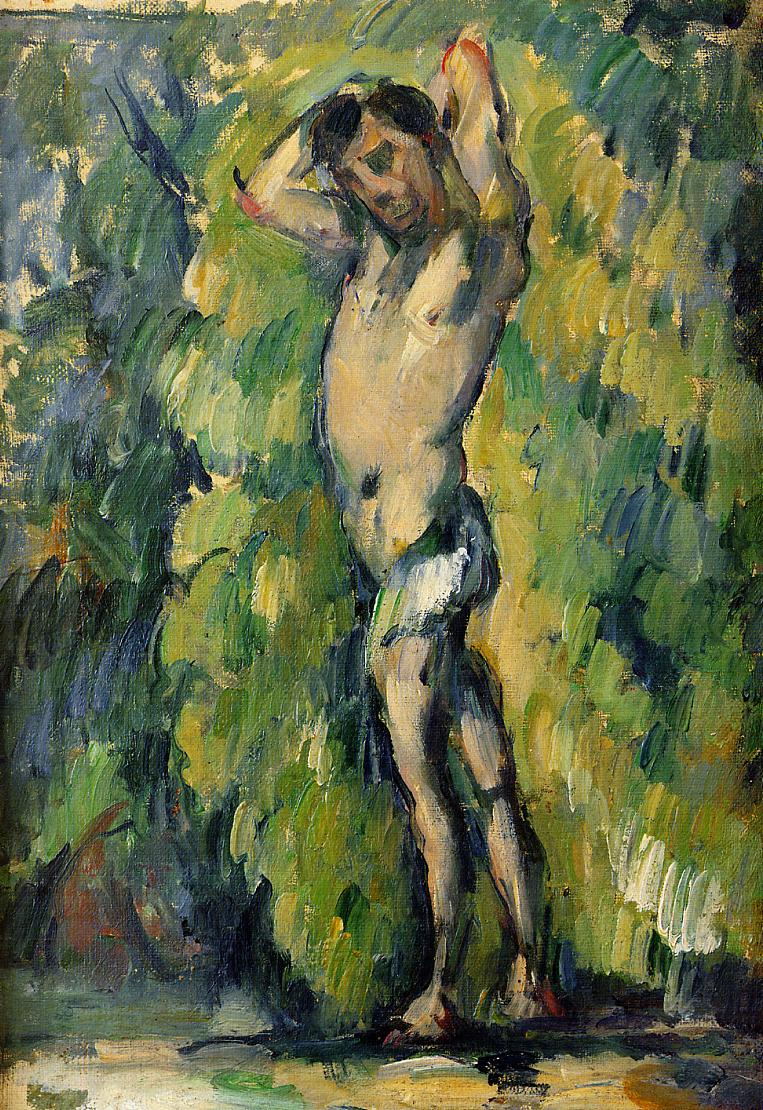What artistic techniques can we observe in this painting that are signature to the impressionist movement? In this painting, you can observe several techniques characteristic of Impressionism. Firstly, the use of thick, visible brushstrokes adds texture and vitality, emphasizing the play of light and shadow rather than precise detail. Secondly, the painting focuses on capturing natural scenery with an immediate, almost snapshot-like quality, reflecting the impressionists' focus on moments in time. Lastly, the vibrant, unblended colors create a lively canvas that appears almost more vivid when viewed from a distance, a method used by impressionists to simulate the dynamic effects of natural light. 